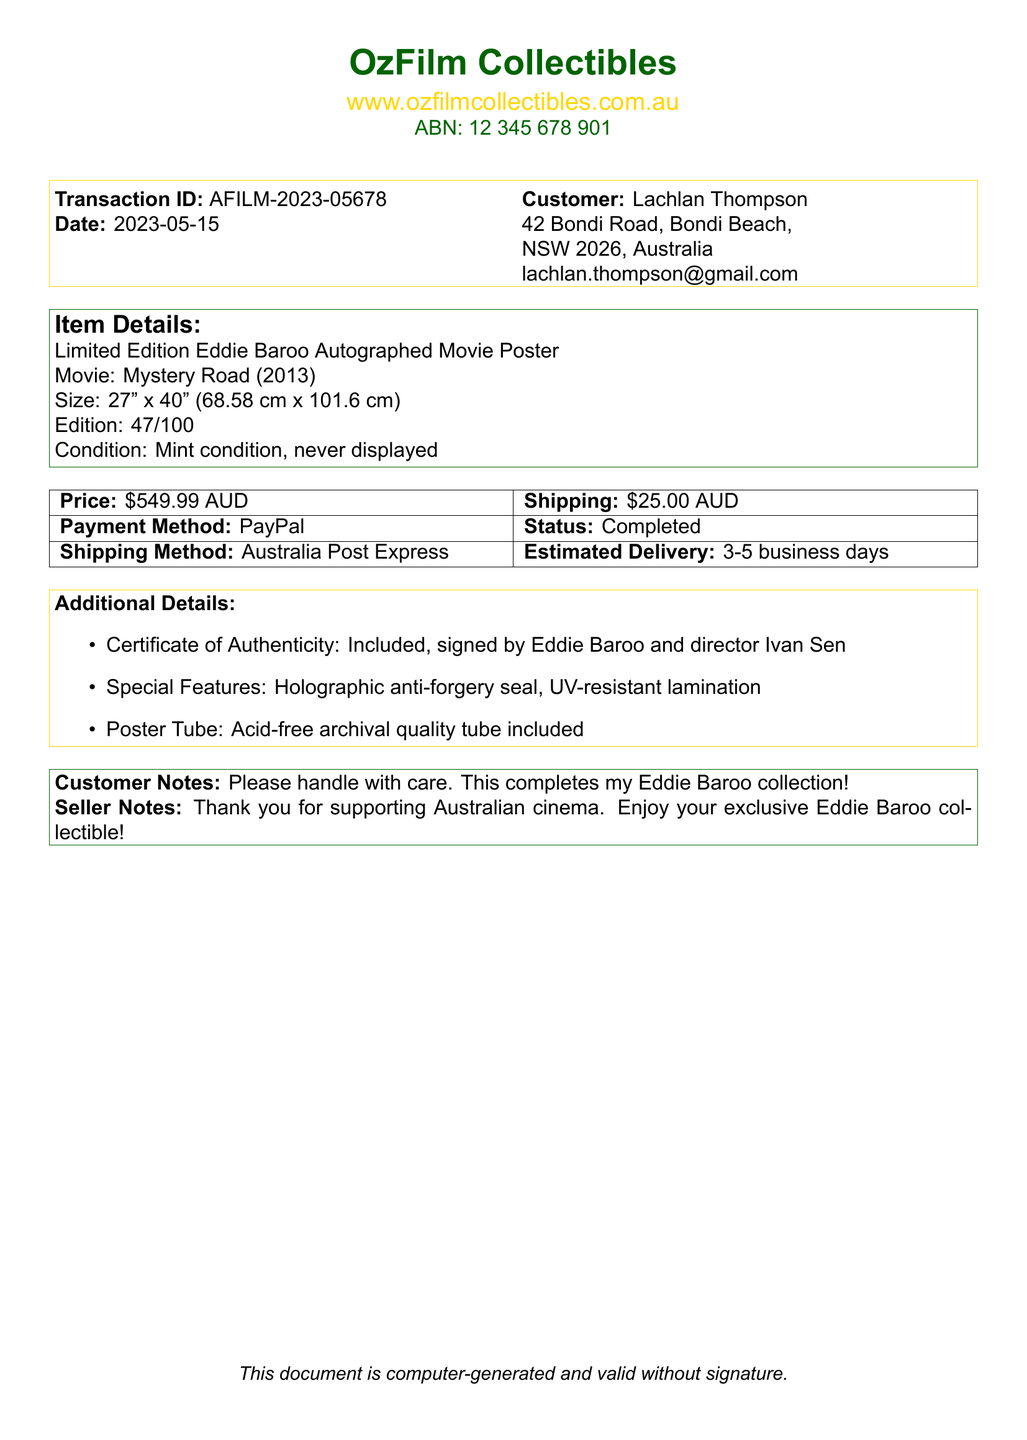What is the transaction ID? The transaction ID is a unique identifier for the purchase, listed in the document.
Answer: AFILM-2023-05678 Who is the customer? The customer's name is provided at the top of the transaction, indicating who made the purchase.
Answer: Lachlan Thompson What is the price of the movie poster? The price is clearly stated in the document and refers to the cost of the item.
Answer: $549.99 AUD What is the seller's website? The website for the seller is specified in the document, allowing you to visit their site.
Answer: www.ozfilmcollectibles.com.au What is the shipping method used? The document mentions the shipping method for the delivery of the purchased item.
Answer: Australia Post Express In what condition is the movie poster? The condition of the item is provided to reassure the customer about its state.
Answer: Mint condition, never displayed What is included with the poster? The additional details section outlines what extras come with the purchase.
Answer: Certificate of Authenticity How long is the estimated delivery time? The estimated delivery time is listed in the shipping details of the document.
Answer: 3-5 business days What special feature is mentioned for the poster? The document includes a specific feature that enhances the security of the collectible.
Answer: Holographic anti-forgery seal What note did the customer include? The document contains a note from the customer, indicating their feelings about the purchase.
Answer: Please handle with care. This completes my Eddie Baroo collection! 